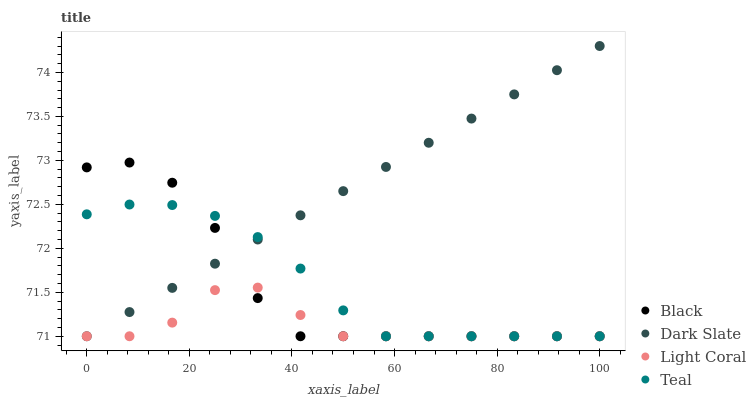Does Light Coral have the minimum area under the curve?
Answer yes or no. Yes. Does Dark Slate have the maximum area under the curve?
Answer yes or no. Yes. Does Black have the minimum area under the curve?
Answer yes or no. No. Does Black have the maximum area under the curve?
Answer yes or no. No. Is Dark Slate the smoothest?
Answer yes or no. Yes. Is Black the roughest?
Answer yes or no. Yes. Is Black the smoothest?
Answer yes or no. No. Is Dark Slate the roughest?
Answer yes or no. No. Does Light Coral have the lowest value?
Answer yes or no. Yes. Does Dark Slate have the highest value?
Answer yes or no. Yes. Does Black have the highest value?
Answer yes or no. No. Does Dark Slate intersect Teal?
Answer yes or no. Yes. Is Dark Slate less than Teal?
Answer yes or no. No. Is Dark Slate greater than Teal?
Answer yes or no. No. 